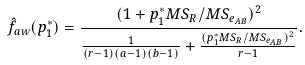Convert formula to latex. <formula><loc_0><loc_0><loc_500><loc_500>\hat { f } _ { a w } ( p _ { 1 } ^ { * } ) & = \frac { ( 1 + p _ { 1 } ^ { * } M S _ { R } / M S _ { e _ { A B } } ) ^ { 2 } } { \frac { 1 } { ( r - 1 ) ( a - 1 ) ( b - 1 ) } + \frac { ( p _ { 1 } ^ { * } M S _ { R } / M S _ { e _ { A B } } ) ^ { 2 } } { r - 1 } } .</formula> 